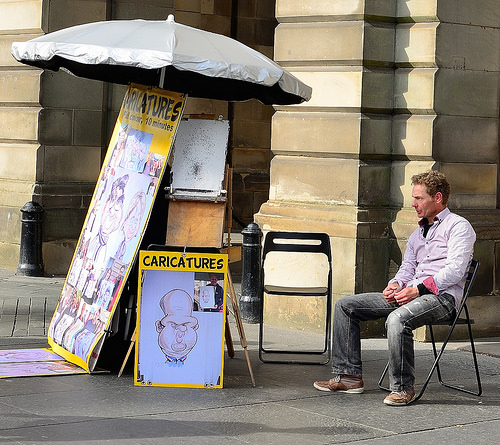<image>
Is there a sign above the sidewalk? No. The sign is not positioned above the sidewalk. The vertical arrangement shows a different relationship. 